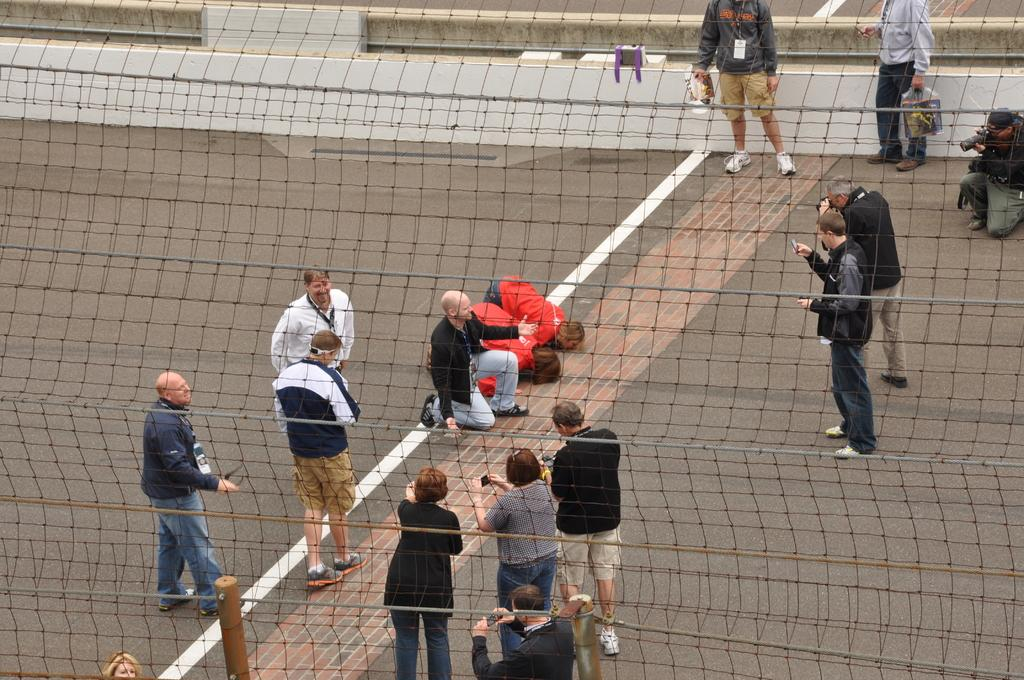What is in the foreground of the image? There is a net fence in the foreground of the image. What can be seen on the floor in the image? There are people standing on the floor. What are some people doing in the image? Some people are holding cameras and capturing images. What type of farm animals can be seen in the image? There are no farm animals present in the image. What subject is being taught in the image? There is no teaching or classroom setting depicted in the image. 